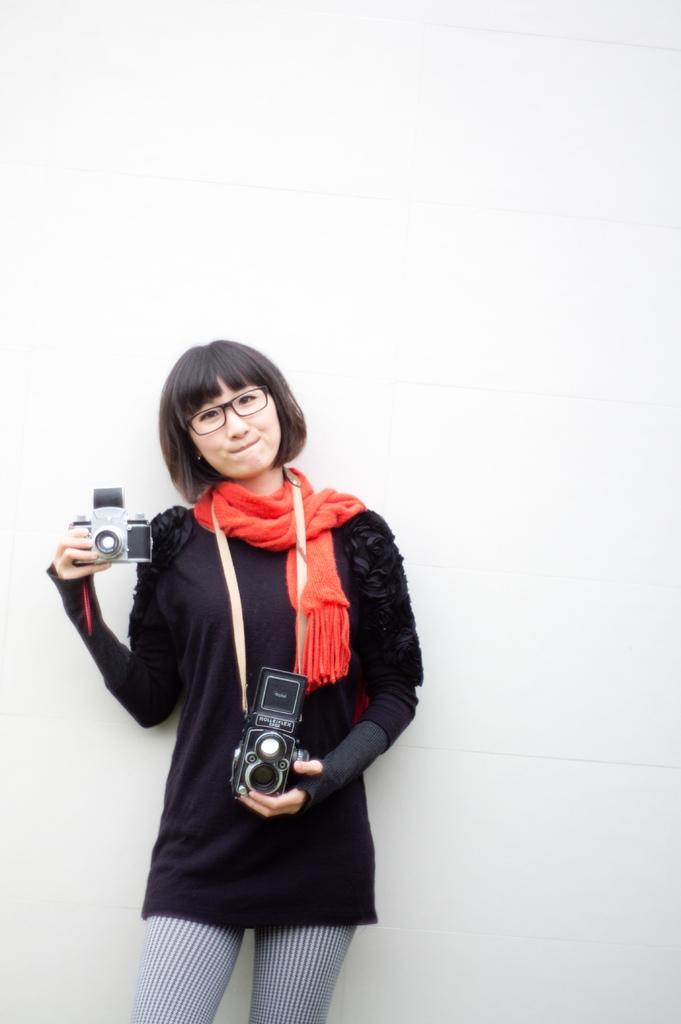Describe this image in one or two sentences. In this image we can see a lady standing and holding cameras. In the background there is a wall. 